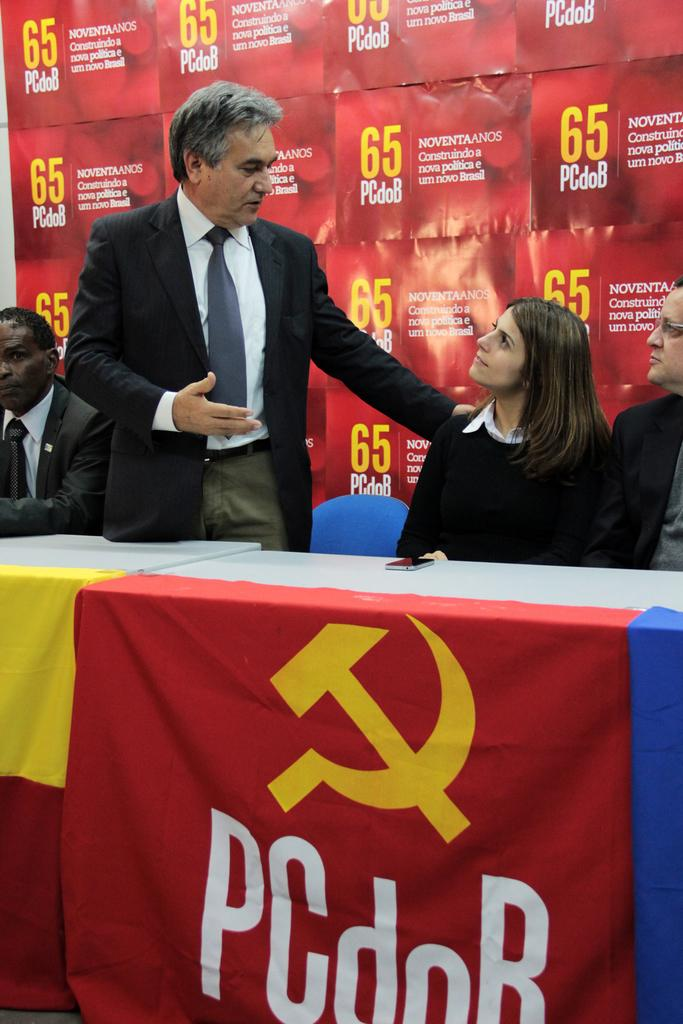What is the man doing in the image? The man is standing near a desk and placing his hand on a woman's shoulder. Where is the woman located in the image? The woman is sitting near a table. What can be seen in the background of the image? There are posters in the background of the image. What type of scarf is the man wearing in the image? There is no scarf visible on the man in the image. How many spiders are crawling on the desk in the image? There are no spiders present in the image. 